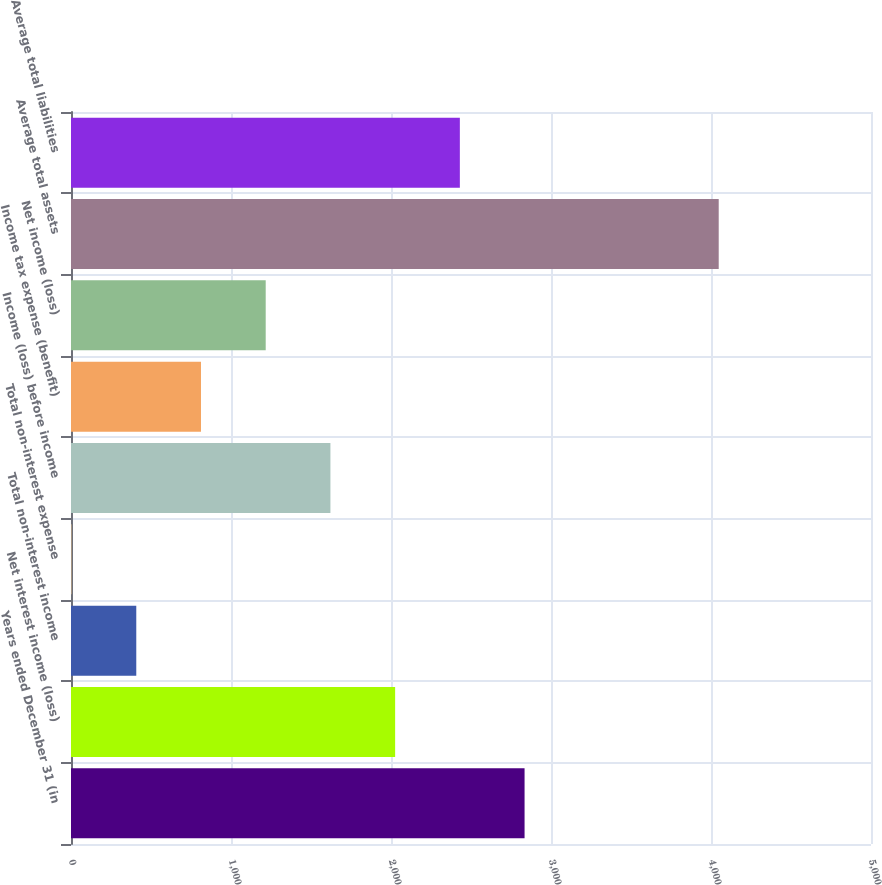Convert chart. <chart><loc_0><loc_0><loc_500><loc_500><bar_chart><fcel>Years ended December 31 (in<fcel>Net interest income (loss)<fcel>Total non-interest income<fcel>Total non-interest expense<fcel>Income (loss) before income<fcel>Income tax expense (benefit)<fcel>Net income (loss)<fcel>Average total assets<fcel>Average total liabilities<nl><fcel>2834.79<fcel>2025.85<fcel>407.97<fcel>3.5<fcel>1621.38<fcel>812.44<fcel>1216.91<fcel>4048.2<fcel>2430.32<nl></chart> 